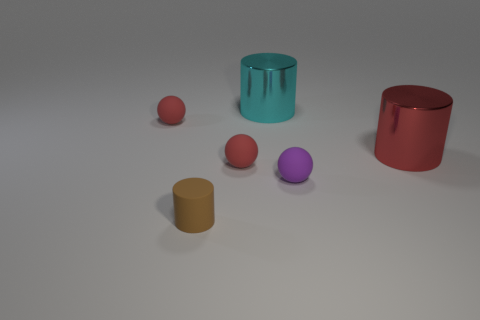Add 3 cylinders. How many objects exist? 9 Subtract all purple matte things. Subtract all small rubber balls. How many objects are left? 2 Add 2 tiny red rubber things. How many tiny red rubber things are left? 4 Add 6 small brown things. How many small brown things exist? 7 Subtract 0 yellow cylinders. How many objects are left? 6 